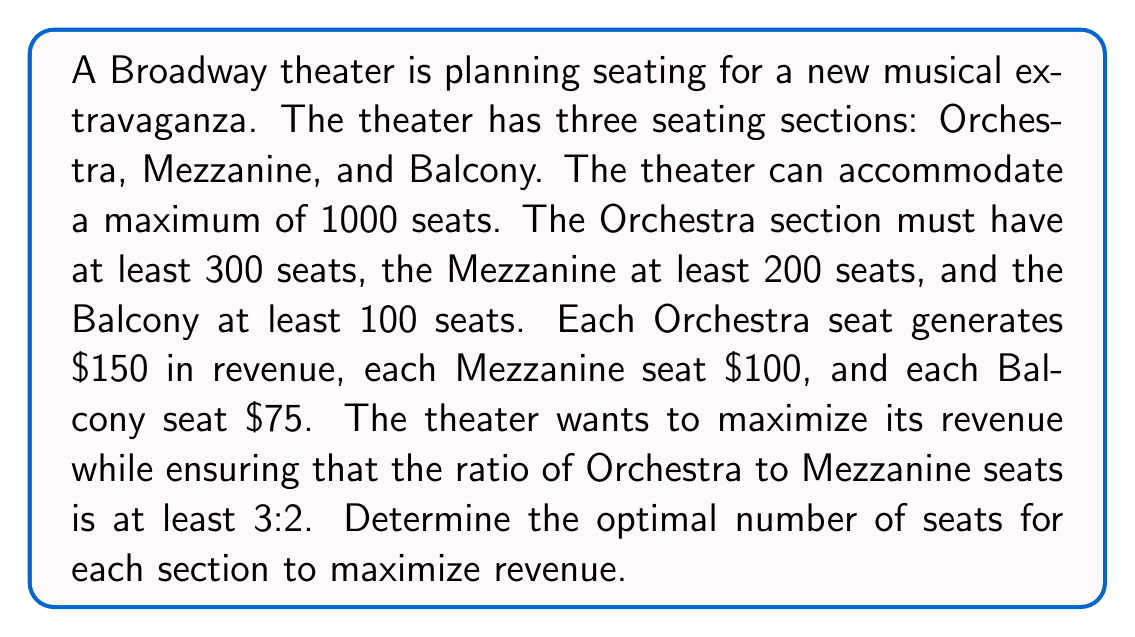What is the answer to this math problem? Let's approach this problem using linear programming:

1. Define variables:
   $x$ = number of Orchestra seats
   $y$ = number of Mezzanine seats
   $z$ = number of Balcony seats

2. Objective function (maximize revenue):
   $\text{Maximize } 150x + 100y + 75z$

3. Constraints:
   a) Total seats: $x + y + z \leq 1000$
   b) Minimum seats per section:
      $x \geq 300$
      $y \geq 200$
      $z \geq 100$
   c) Ratio of Orchestra to Mezzanine: $x \geq 1.5y$

4. Set up the linear programming problem:
   $$
   \begin{align*}
   \text{Maximize: } & 150x + 100y + 75z \\
   \text{Subject to: } & x + y + z \leq 1000 \\
   & x \geq 300 \\
   & y \geq 200 \\
   & z \geq 100 \\
   & x \geq 1.5y \\
   & x, y, z \geq 0 \text{ and integer}
   \end{align*}
   $$

5. Solve using a linear programming solver (e.g., Simplex method):
   The optimal solution is:
   $x = 540$ (Orchestra seats)
   $y = 360$ (Mezzanine seats)
   $z = 100$ (Balcony seats)

6. Verify constraints:
   - Total seats: $540 + 360 + 100 = 1000$ (≤ 1000)
   - Minimum seats: 540 > 300, 360 > 200, 100 ≥ 100
   - Ratio: $540 \geq 1.5 * 360$ (540 ≥ 540)

7. Calculate maximum revenue:
   $150 * 540 + 100 * 360 + 75 * 100 = 81,000 + 36,000 + 7,500 = 124,500$

Therefore, the optimal seating arrangement to maximize revenue is 540 Orchestra seats, 360 Mezzanine seats, and 100 Balcony seats.
Answer: The optimal seating arrangement is 540 Orchestra seats, 360 Mezzanine seats, and 100 Balcony seats, generating a maximum revenue of $124,500. 